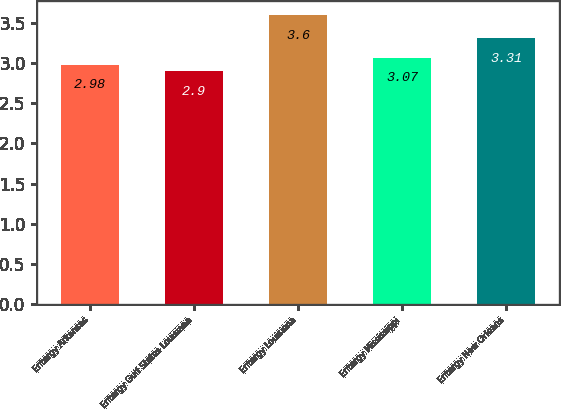Convert chart. <chart><loc_0><loc_0><loc_500><loc_500><bar_chart><fcel>Entergy Arkansas<fcel>Entergy Gulf States Louisiana<fcel>Entergy Louisiana<fcel>Entergy Mississippi<fcel>Entergy New Orleans<nl><fcel>2.98<fcel>2.9<fcel>3.6<fcel>3.07<fcel>3.31<nl></chart> 